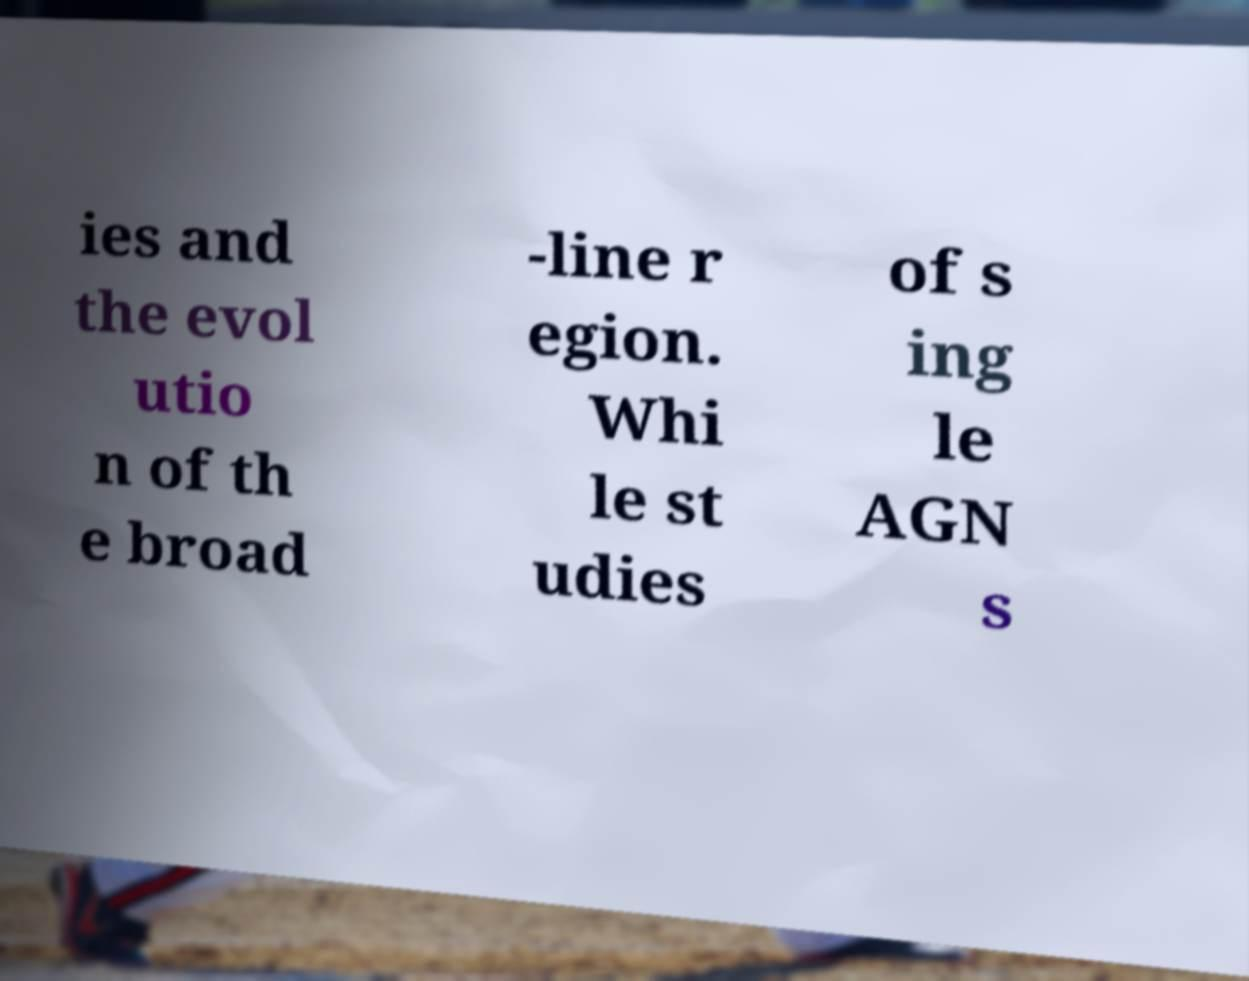There's text embedded in this image that I need extracted. Can you transcribe it verbatim? ies and the evol utio n of th e broad -line r egion. Whi le st udies of s ing le AGN s 